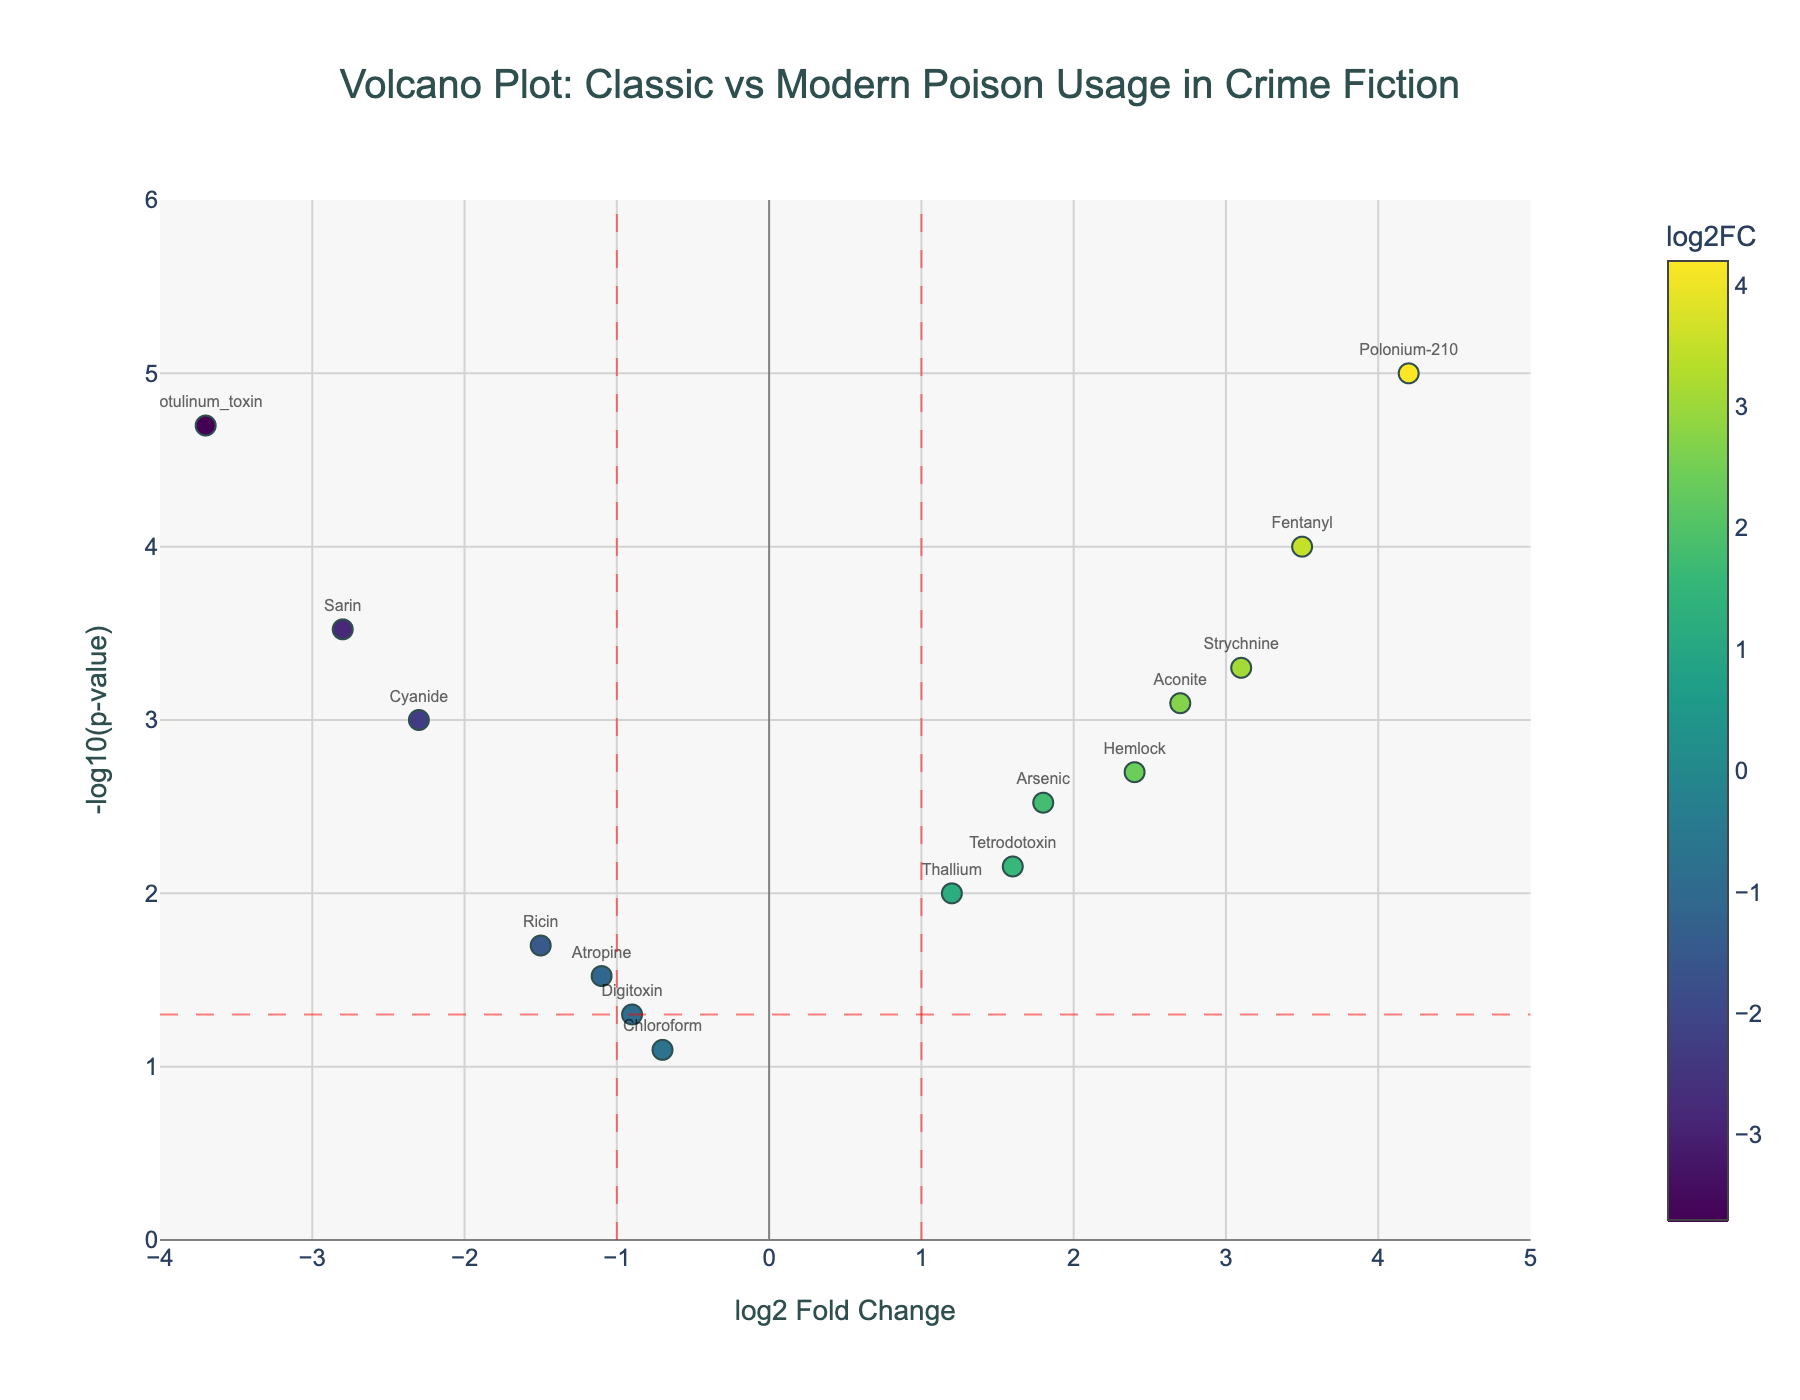Which compound has the highest log2 Fold Change? Look for the point that is furthest to the right on the x-axis to identify the highest log2 Fold Change. Polonium-210 is at the far right with a log2 Fold Change of 4.2.
Answer: Polonium-210 How many compounds have a p-value less than 0.01? For each compound, check if its y-axis value (-log10(p-value)) is greater than 2 (since -log10(p-value) where p = 0.01 is 2). There are eight such points: Cyanide, Arsenic, Strychnine, Aconite, Hemlock, Fentanyl, Sarin, and Polonium-210.
Answer: 8 Which compound is associated with the lowest p-value? Look for the point that is highest on the y-axis to identify the lowest p-value (since -log10(p-value) will be maximized). Polonium-210 is the highest on the y-axis with a -log10(p-value) value of approximately 5.
Answer: Polonium-210 How many compounds have a log2 Fold Change between -1 and 1? Identify the points between the red vertical lines at x = -1 and x = 1. There are four such points: Ricin, Digitoxin, Atropine, and Chloroform.
Answer: 4 Which compound has a log2 Fold Change closest to zero and what is its value? Among the plotted points, identify the one closest to the origin on the x-axis. Chloroform has the smallest absolute log2 Fold Change close to zero, which is -0.7.
Answer: Chloroform, -0.7 Which two compounds have the most statistically significant difference in p-value and log2 Fold Change? Compare points that are on opposite sides of the red lines and have the largest difference in y-axis values (high and low -log10(p-value)). Polonium-210 and Botulinum_toxin have the greatest difference, with Polonium-210 at (4.2, ~5) and Botulinum_toxin at (-3.7, ~4.7).
Answer: Polonium-210 and Botulinum_toxin What is the log2 Fold Change of Aconite? Look for the text label for Aconite and see its corresponding x-axis value. Aconite has a log2 Fold Change of 2.7.
Answer: 2.7 Are there more compounds with positive or negative log2 Fold Change values? Count the number of points on the right side (positive x-axis) compared to the left side (negative x-axis). There are 9 points to the right and 6 points to the left.
Answer: Positive Which compound shows the smallest effectiveness (log2 Fold Change) with a p-value less than 0.05? Identify the points below the horizontal red line that meets the vertical red lines and find the one closest to zero. Digitoxin is the closest to zero with a log2 Fold Change of -0.9.
Answer: Digitoxin 